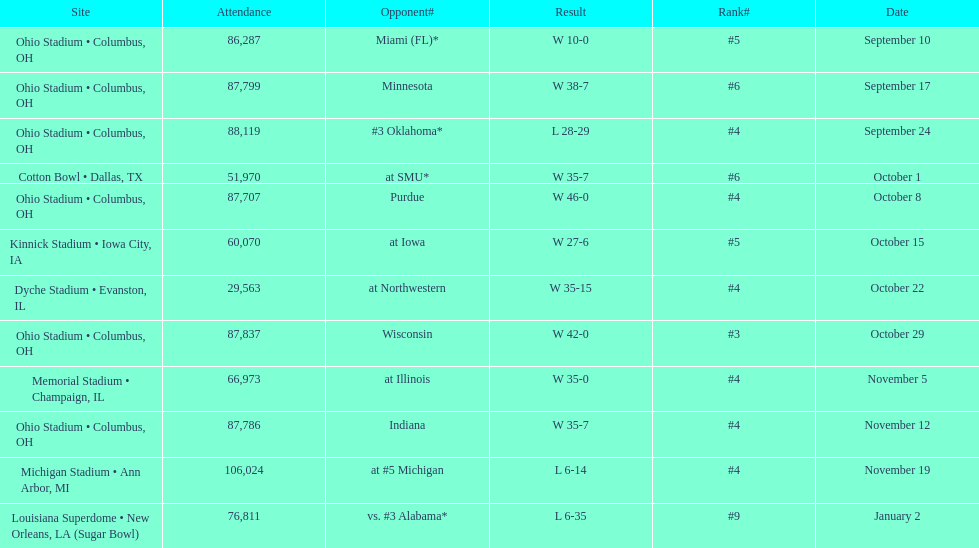Which date was attended by the most people? November 19. 